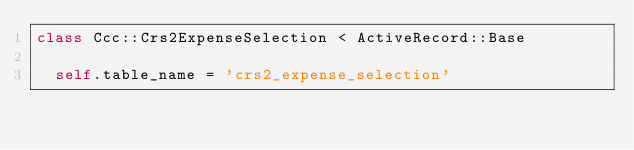<code> <loc_0><loc_0><loc_500><loc_500><_Ruby_>class Ccc::Crs2ExpenseSelection < ActiveRecord::Base

  self.table_name = 'crs2_expense_selection'</code> 